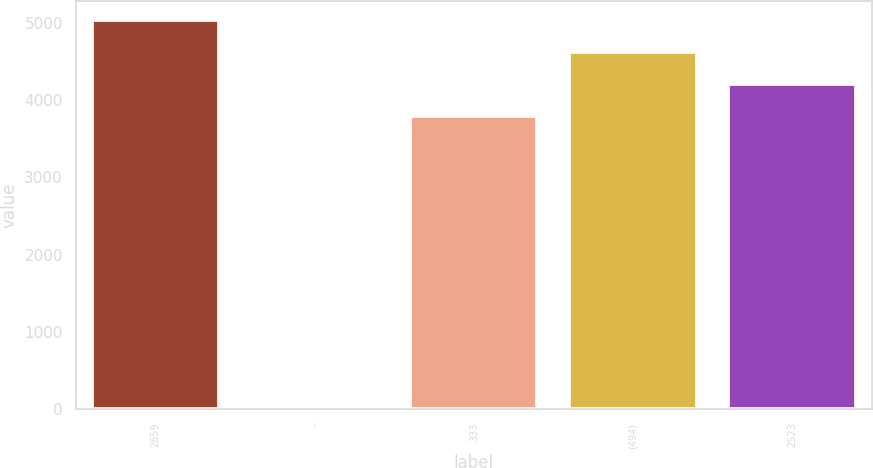<chart> <loc_0><loc_0><loc_500><loc_500><bar_chart><fcel>2859<fcel>-<fcel>333<fcel>(494)<fcel>2523<nl><fcel>5036.4<fcel>42<fcel>3795<fcel>4622.6<fcel>4208.8<nl></chart> 